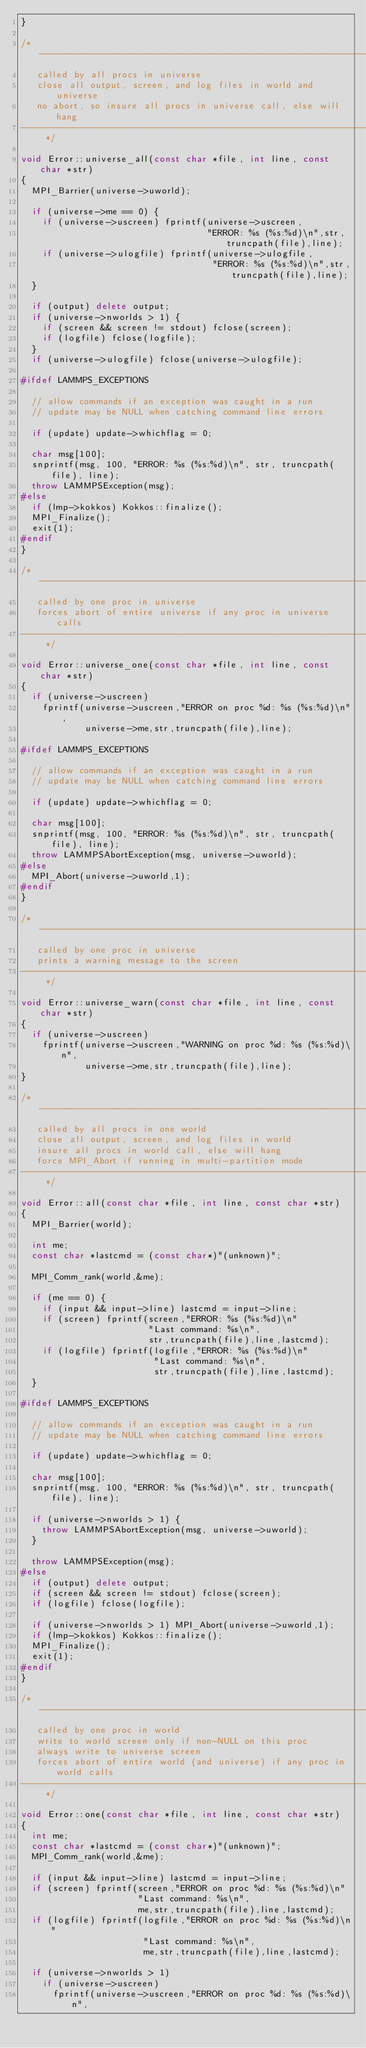Convert code to text. <code><loc_0><loc_0><loc_500><loc_500><_C++_>}

/* ----------------------------------------------------------------------
   called by all procs in universe
   close all output, screen, and log files in world and universe
   no abort, so insure all procs in universe call, else will hang
------------------------------------------------------------------------- */

void Error::universe_all(const char *file, int line, const char *str)
{
  MPI_Barrier(universe->uworld);

  if (universe->me == 0) {
    if (universe->uscreen) fprintf(universe->uscreen,
                                   "ERROR: %s (%s:%d)\n",str,truncpath(file),line);
    if (universe->ulogfile) fprintf(universe->ulogfile,
                                    "ERROR: %s (%s:%d)\n",str,truncpath(file),line);
  }

  if (output) delete output;
  if (universe->nworlds > 1) {
    if (screen && screen != stdout) fclose(screen);
    if (logfile) fclose(logfile);
  }
  if (universe->ulogfile) fclose(universe->ulogfile);

#ifdef LAMMPS_EXCEPTIONS

  // allow commands if an exception was caught in a run
  // update may be NULL when catching command line errors

  if (update) update->whichflag = 0;

  char msg[100];
  snprintf(msg, 100, "ERROR: %s (%s:%d)\n", str, truncpath(file), line);
  throw LAMMPSException(msg);
#else
  if (lmp->kokkos) Kokkos::finalize();
  MPI_Finalize();
  exit(1);
#endif
}

/* ----------------------------------------------------------------------
   called by one proc in universe
   forces abort of entire universe if any proc in universe calls
------------------------------------------------------------------------- */

void Error::universe_one(const char *file, int line, const char *str)
{
  if (universe->uscreen)
    fprintf(universe->uscreen,"ERROR on proc %d: %s (%s:%d)\n",
            universe->me,str,truncpath(file),line);

#ifdef LAMMPS_EXCEPTIONS

  // allow commands if an exception was caught in a run
  // update may be NULL when catching command line errors

  if (update) update->whichflag = 0;

  char msg[100];
  snprintf(msg, 100, "ERROR: %s (%s:%d)\n", str, truncpath(file), line);
  throw LAMMPSAbortException(msg, universe->uworld);
#else
  MPI_Abort(universe->uworld,1);
#endif
}

/* ----------------------------------------------------------------------
   called by one proc in universe
   prints a warning message to the screen
------------------------------------------------------------------------- */

void Error::universe_warn(const char *file, int line, const char *str)
{
  if (universe->uscreen)
    fprintf(universe->uscreen,"WARNING on proc %d: %s (%s:%d)\n",
            universe->me,str,truncpath(file),line);
}

/* ----------------------------------------------------------------------
   called by all procs in one world
   close all output, screen, and log files in world
   insure all procs in world call, else will hang
   force MPI_Abort if running in multi-partition mode
------------------------------------------------------------------------- */

void Error::all(const char *file, int line, const char *str)
{
  MPI_Barrier(world);

  int me;
  const char *lastcmd = (const char*)"(unknown)";

  MPI_Comm_rank(world,&me);

  if (me == 0) {
    if (input && input->line) lastcmd = input->line;
    if (screen) fprintf(screen,"ERROR: %s (%s:%d)\n"
                        "Last command: %s\n",
                        str,truncpath(file),line,lastcmd);
    if (logfile) fprintf(logfile,"ERROR: %s (%s:%d)\n"
                         "Last command: %s\n",
                         str,truncpath(file),line,lastcmd);
  }

#ifdef LAMMPS_EXCEPTIONS

  // allow commands if an exception was caught in a run
  // update may be NULL when catching command line errors

  if (update) update->whichflag = 0;

  char msg[100];
  snprintf(msg, 100, "ERROR: %s (%s:%d)\n", str, truncpath(file), line);

  if (universe->nworlds > 1) {
    throw LAMMPSAbortException(msg, universe->uworld);
  }

  throw LAMMPSException(msg);
#else
  if (output) delete output;
  if (screen && screen != stdout) fclose(screen);
  if (logfile) fclose(logfile);

  if (universe->nworlds > 1) MPI_Abort(universe->uworld,1);
  if (lmp->kokkos) Kokkos::finalize();
  MPI_Finalize();
  exit(1);
#endif
}

/* ----------------------------------------------------------------------
   called by one proc in world
   write to world screen only if non-NULL on this proc
   always write to universe screen
   forces abort of entire world (and universe) if any proc in world calls
------------------------------------------------------------------------- */

void Error::one(const char *file, int line, const char *str)
{
  int me;
  const char *lastcmd = (const char*)"(unknown)";
  MPI_Comm_rank(world,&me);

  if (input && input->line) lastcmd = input->line;
  if (screen) fprintf(screen,"ERROR on proc %d: %s (%s:%d)\n"
                      "Last command: %s\n",
                      me,str,truncpath(file),line,lastcmd);
  if (logfile) fprintf(logfile,"ERROR on proc %d: %s (%s:%d)\n"
                       "Last command: %s\n",
                       me,str,truncpath(file),line,lastcmd);

  if (universe->nworlds > 1)
    if (universe->uscreen)
      fprintf(universe->uscreen,"ERROR on proc %d: %s (%s:%d)\n",</code> 